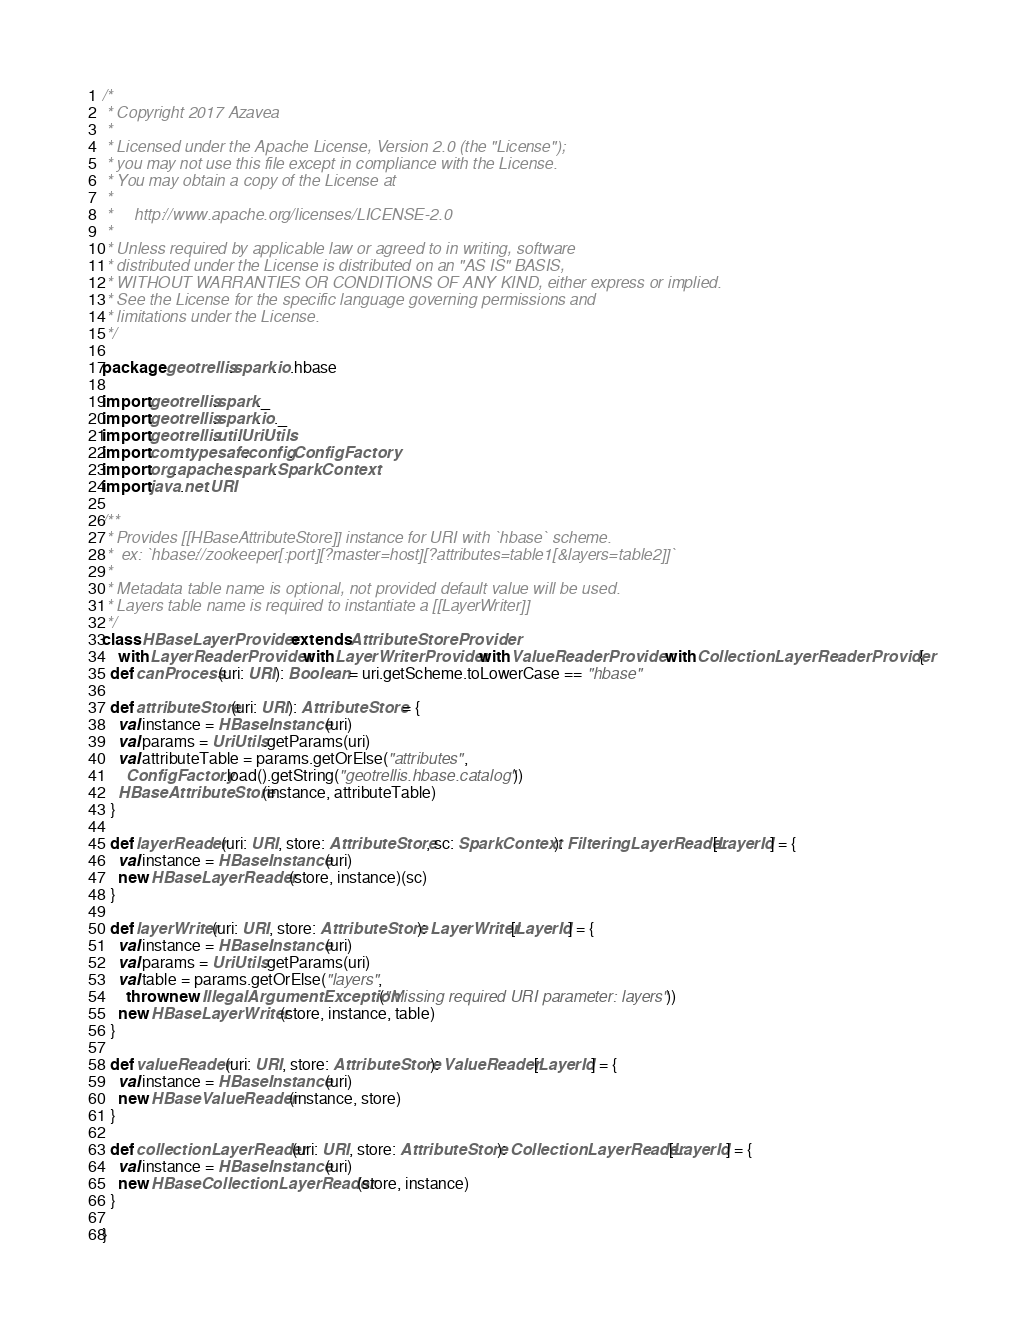Convert code to text. <code><loc_0><loc_0><loc_500><loc_500><_Scala_>/*
 * Copyright 2017 Azavea
 *
 * Licensed under the Apache License, Version 2.0 (the "License");
 * you may not use this file except in compliance with the License.
 * You may obtain a copy of the License at
 *
 *     http://www.apache.org/licenses/LICENSE-2.0
 *
 * Unless required by applicable law or agreed to in writing, software
 * distributed under the License is distributed on an "AS IS" BASIS,
 * WITHOUT WARRANTIES OR CONDITIONS OF ANY KIND, either express or implied.
 * See the License for the specific language governing permissions and
 * limitations under the License.
 */

package geotrellis.spark.io.hbase

import geotrellis.spark._
import geotrellis.spark.io._
import geotrellis.util.UriUtils
import com.typesafe.config.ConfigFactory
import org.apache.spark.SparkContext
import java.net.URI

/**
 * Provides [[HBaseAttributeStore]] instance for URI with `hbase` scheme.
 *  ex: `hbase://zookeeper[:port][?master=host][?attributes=table1[&layers=table2]]`
 *
 * Metadata table name is optional, not provided default value will be used.
 * Layers table name is required to instantiate a [[LayerWriter]]
 */
class HBaseLayerProvider extends AttributeStoreProvider
    with LayerReaderProvider with LayerWriterProvider with ValueReaderProvider with CollectionLayerReaderProvider {
  def canProcess(uri: URI): Boolean = uri.getScheme.toLowerCase == "hbase"

  def attributeStore(uri: URI): AttributeStore = {
    val instance = HBaseInstance(uri)
    val params = UriUtils.getParams(uri)
    val attributeTable = params.getOrElse("attributes",
      ConfigFactory.load().getString("geotrellis.hbase.catalog"))
    HBaseAttributeStore(instance, attributeTable)
  }

  def layerReader(uri: URI, store: AttributeStore, sc: SparkContext): FilteringLayerReader[LayerId] = {
    val instance = HBaseInstance(uri)
    new HBaseLayerReader(store, instance)(sc)
  }

  def layerWriter(uri: URI, store: AttributeStore): LayerWriter[LayerId] = {
    val instance = HBaseInstance(uri)
    val params = UriUtils.getParams(uri)
    val table = params.getOrElse("layers",
      throw new IllegalArgumentException("Missing required URI parameter: layers"))
    new HBaseLayerWriter(store, instance, table)
  }

  def valueReader(uri: URI, store: AttributeStore): ValueReader[LayerId] = {
    val instance = HBaseInstance(uri)
    new HBaseValueReader(instance, store)
  }

  def collectionLayerReader(uri: URI, store: AttributeStore): CollectionLayerReader[LayerId] = {
    val instance = HBaseInstance(uri)
    new HBaseCollectionLayerReader(store, instance)
  }

}
</code> 